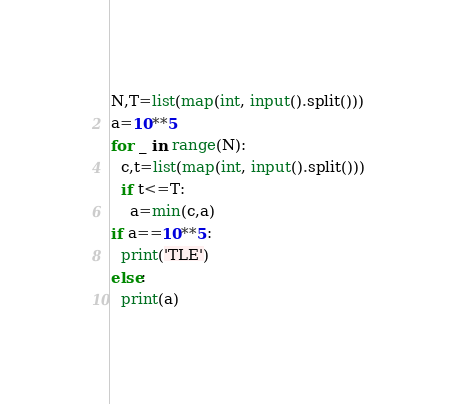<code> <loc_0><loc_0><loc_500><loc_500><_Python_>N,T=list(map(int, input().split()))
a=10**5
for _ in range(N):
  c,t=list(map(int, input().split()))
  if t<=T:
    a=min(c,a)
if a==10**5:
  print('TLE')
else:
  print(a)</code> 